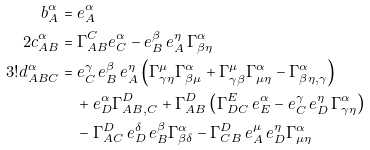Convert formula to latex. <formula><loc_0><loc_0><loc_500><loc_500>b _ { A } ^ { \alpha } & = e _ { A } ^ { \alpha } \\ 2 c _ { A B } ^ { \alpha } & = \Gamma ^ { C } _ { A B } e _ { C } ^ { \alpha } - e _ { B } ^ { \beta } \, e _ { A } ^ { \eta } \, \Gamma _ { \beta \eta } ^ { \alpha } \\ 3 ! d _ { A B C } ^ { \alpha } & = e _ { C } ^ { \gamma } \, e _ { B } ^ { \beta } \, e _ { A } ^ { \eta } \left ( \Gamma _ { \gamma \eta } ^ { \mu } \Gamma _ { \beta \mu } ^ { \alpha } + \Gamma _ { \gamma \beta } ^ { \mu } \Gamma _ { \mu \eta } ^ { \alpha } - \Gamma _ { \beta \eta , \gamma } ^ { \alpha } \right ) \\ & \quad + e _ { D } ^ { \alpha } \Gamma ^ { D } _ { A B , C } + \Gamma ^ { D } _ { A B } \left ( \Gamma ^ { E } _ { D C } \, e _ { E } ^ { \alpha } - e _ { C } ^ { \gamma } \, e _ { D } ^ { \eta } \, \Gamma _ { \gamma \eta } ^ { \alpha } \right ) \\ & \quad - \Gamma ^ { D } _ { A C } \, e _ { D } ^ { \delta } \, e _ { B } ^ { \beta } \Gamma _ { \beta \delta } ^ { \alpha } - \Gamma ^ { D } _ { C B } \, e _ { A } ^ { \mu } \, e _ { D } ^ { \eta } \Gamma _ { \mu \eta } ^ { \alpha }</formula> 